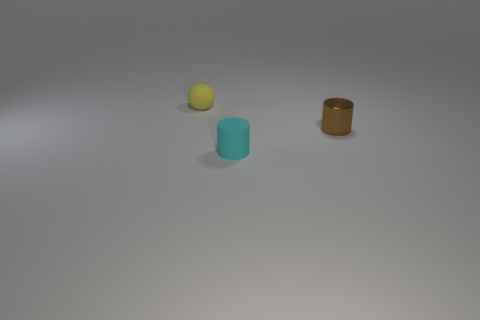Add 2 red balls. How many objects exist? 5 Subtract all cylinders. How many objects are left? 1 Subtract 0 cyan cubes. How many objects are left? 3 Subtract all blue metallic cylinders. Subtract all small cyan cylinders. How many objects are left? 2 Add 3 tiny brown metallic cylinders. How many tiny brown metallic cylinders are left? 4 Add 1 cyan cylinders. How many cyan cylinders exist? 2 